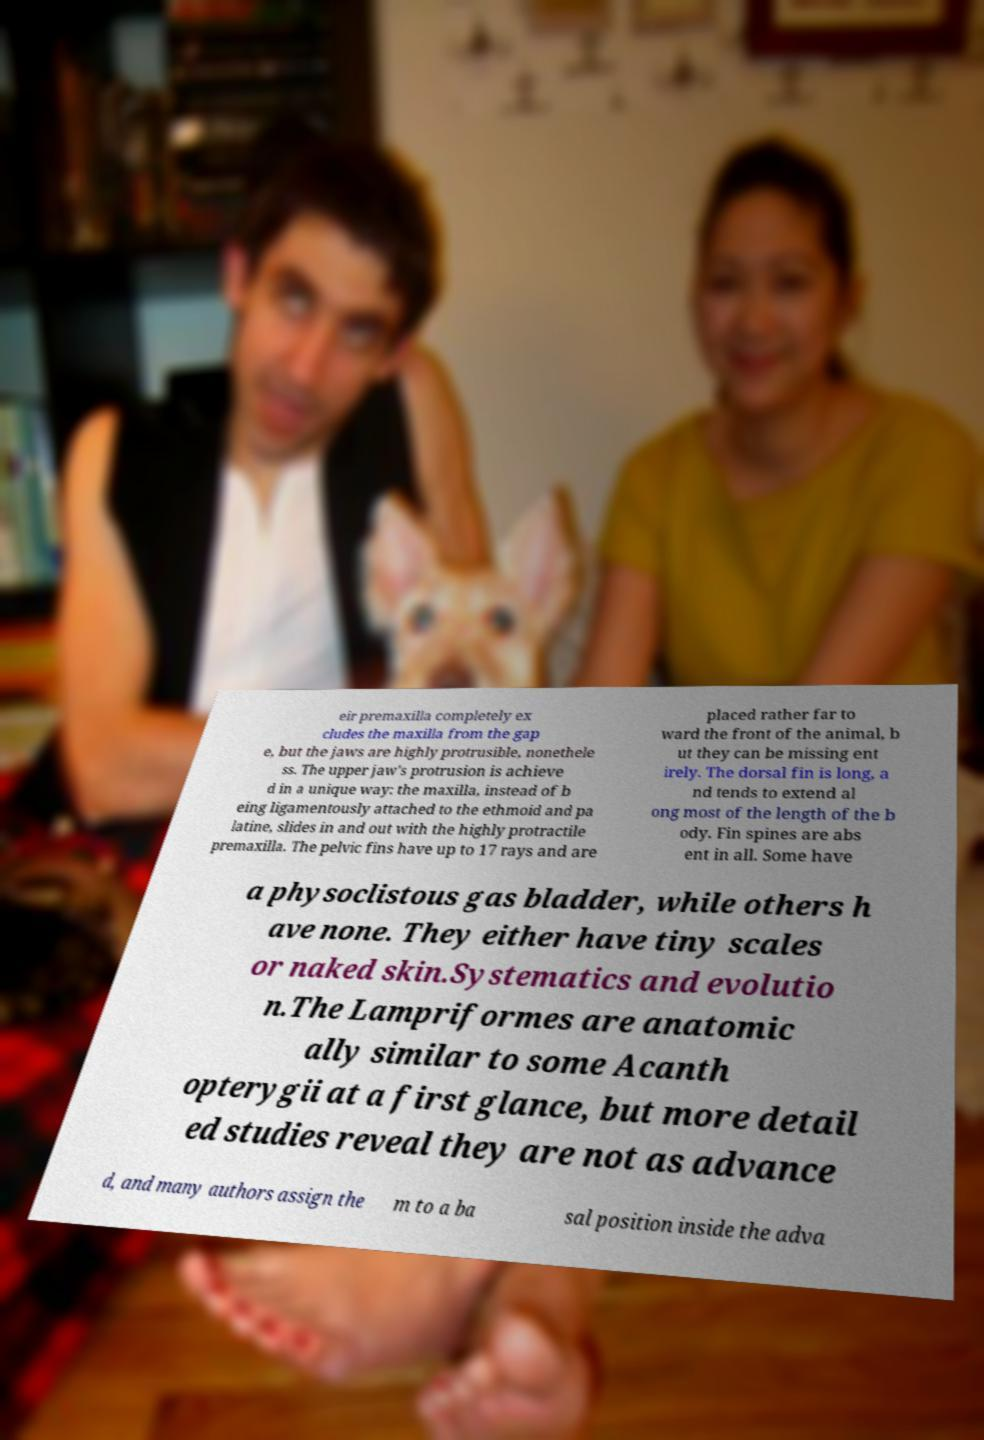Please identify and transcribe the text found in this image. eir premaxilla completely ex cludes the maxilla from the gap e, but the jaws are highly protrusible, nonethele ss. The upper jaw's protrusion is achieve d in a unique way: the maxilla, instead of b eing ligamentously attached to the ethmoid and pa latine, slides in and out with the highly protractile premaxilla. The pelvic fins have up to 17 rays and are placed rather far to ward the front of the animal, b ut they can be missing ent irely. The dorsal fin is long, a nd tends to extend al ong most of the length of the b ody. Fin spines are abs ent in all. Some have a physoclistous gas bladder, while others h ave none. They either have tiny scales or naked skin.Systematics and evolutio n.The Lampriformes are anatomic ally similar to some Acanth opterygii at a first glance, but more detail ed studies reveal they are not as advance d, and many authors assign the m to a ba sal position inside the adva 